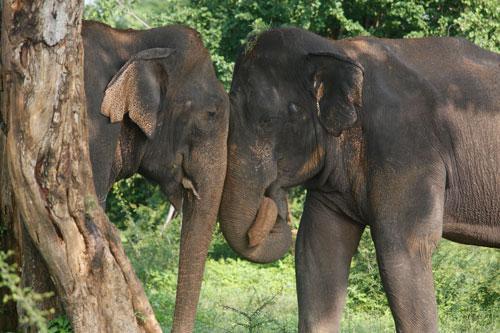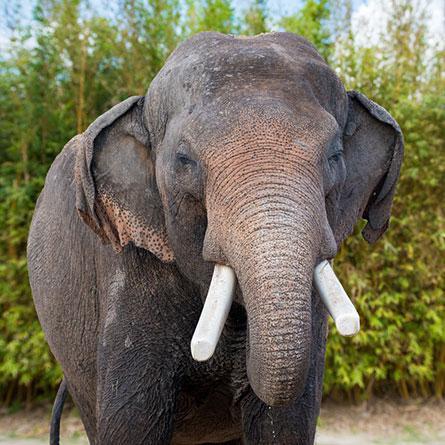The first image is the image on the left, the second image is the image on the right. Assess this claim about the two images: "Two elephants are butting heads in one of the images.". Correct or not? Answer yes or no. Yes. The first image is the image on the left, the second image is the image on the right. Examine the images to the left and right. Is the description "An image shows two elephants face-to-face with their faces touching." accurate? Answer yes or no. Yes. 